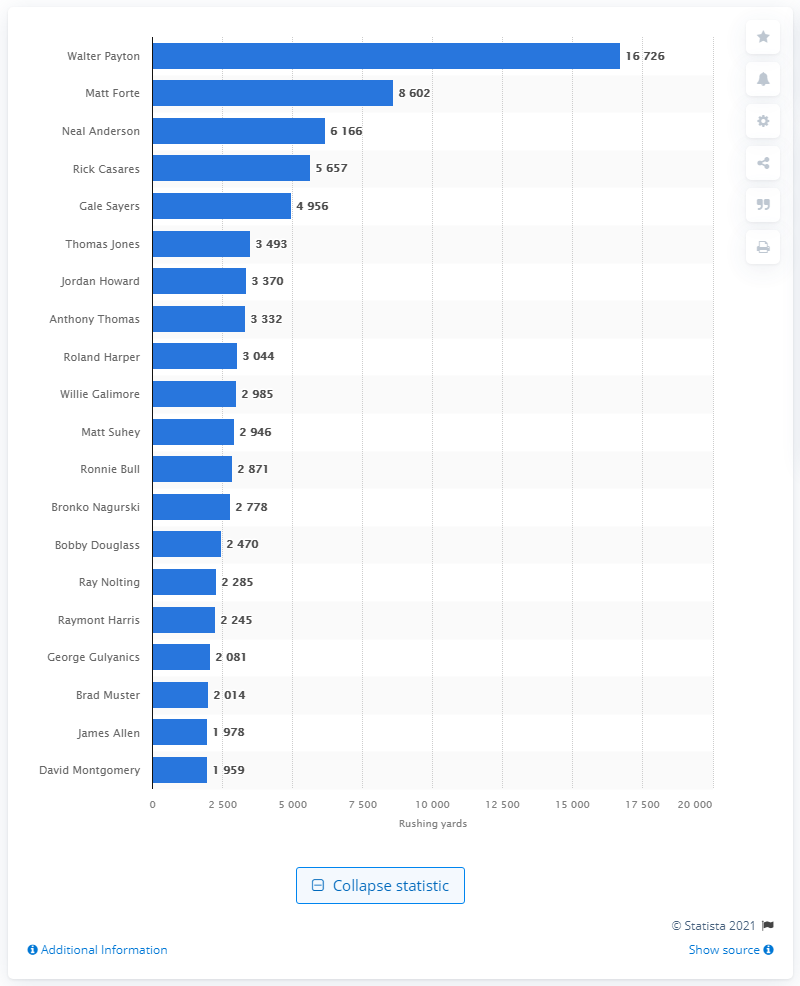Specify some key components in this picture. The career rushing leader of the Chicago Bears is Walter Payton. 